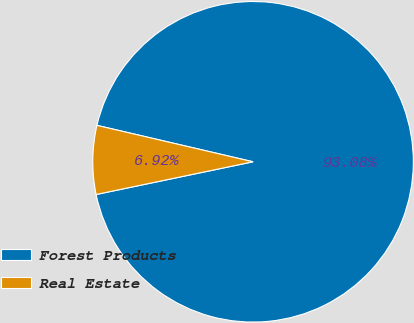Convert chart to OTSL. <chart><loc_0><loc_0><loc_500><loc_500><pie_chart><fcel>Forest Products<fcel>Real Estate<nl><fcel>93.08%<fcel>6.92%<nl></chart> 